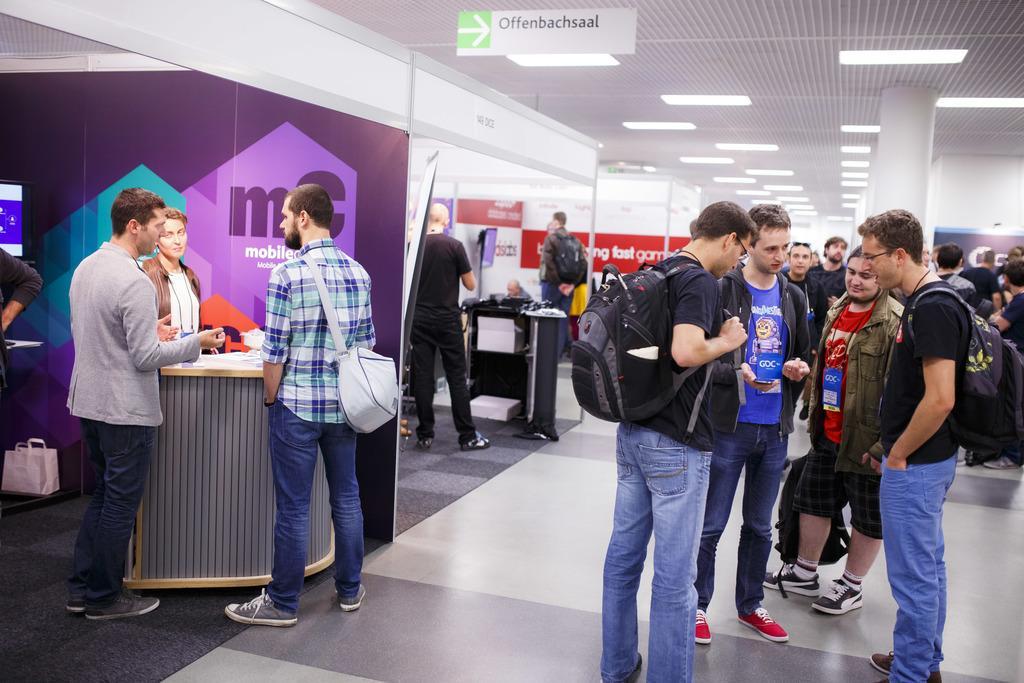Please provide a concise description of this image. This picture is clicked inside the hall. In the center we can see the group of persons standing on the ground and we can see the backpack, sling bag and we can see the pillars, tables on the top of which some items are placed and we can see the text on the banners. At the top there is a roof and the ceiling lights. 